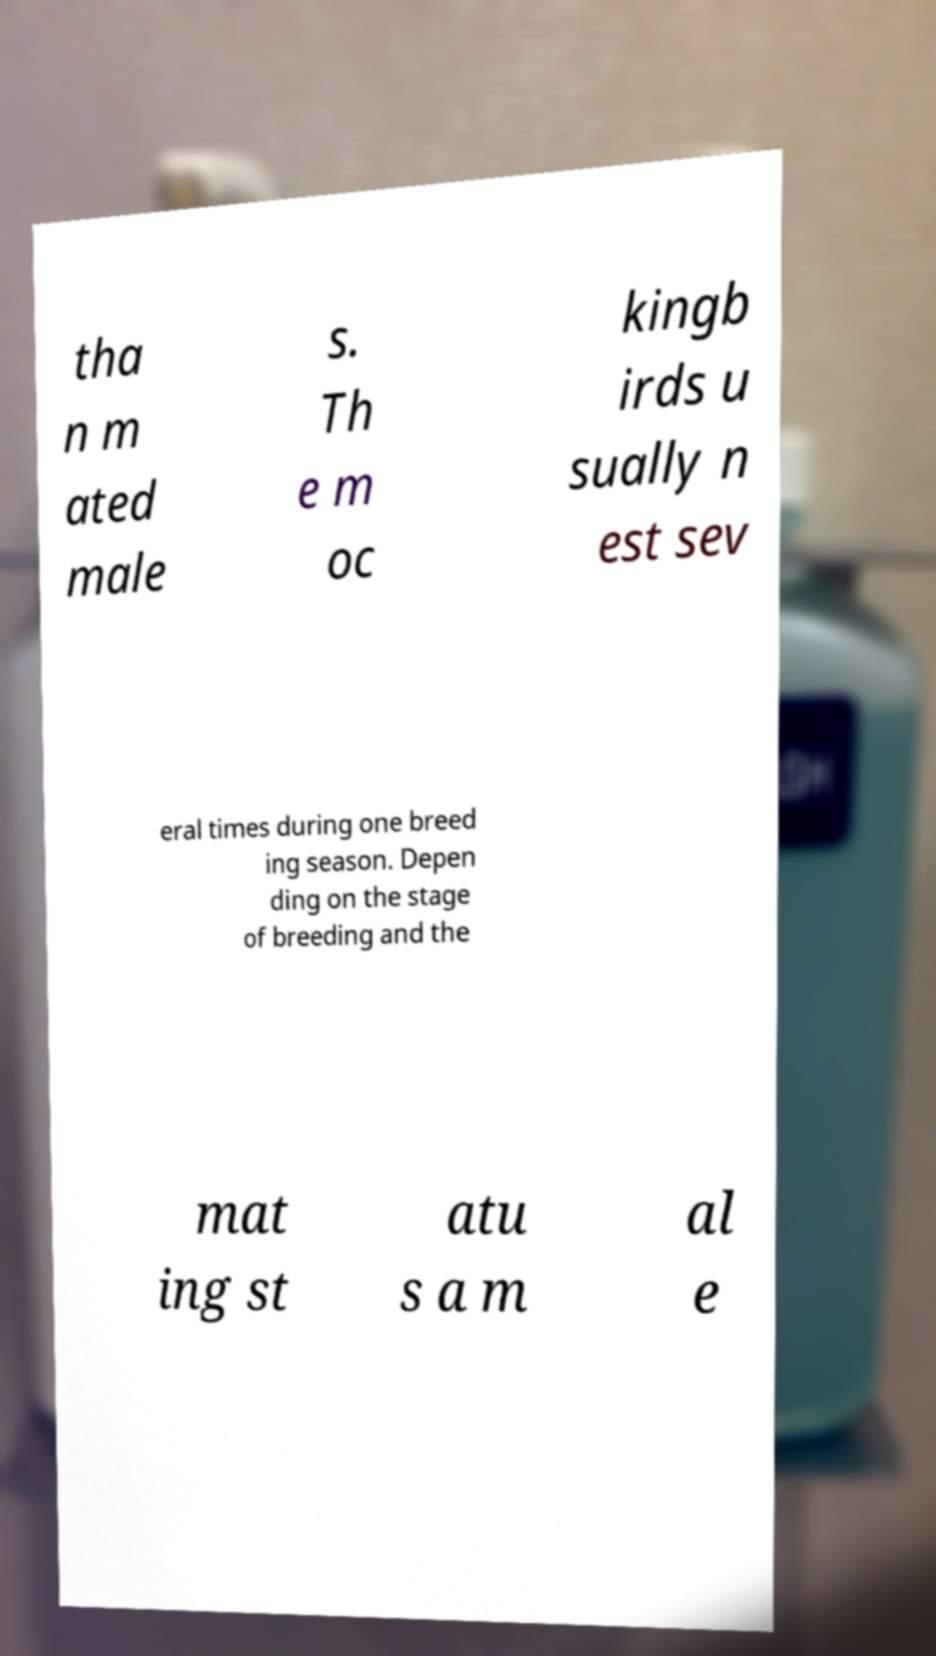Please read and relay the text visible in this image. What does it say? tha n m ated male s. Th e m oc kingb irds u sually n est sev eral times during one breed ing season. Depen ding on the stage of breeding and the mat ing st atu s a m al e 